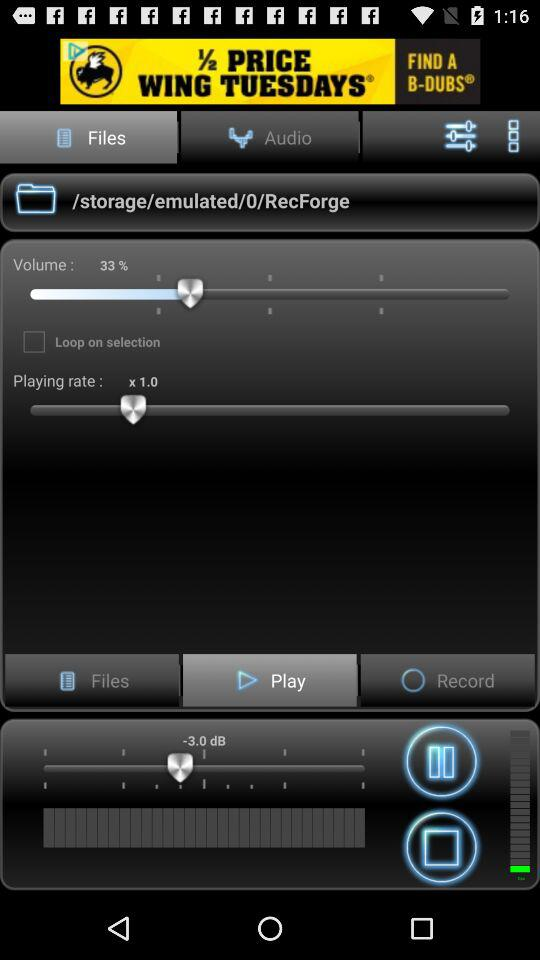What's the playing rate? The playing rate is "× 1.0". 